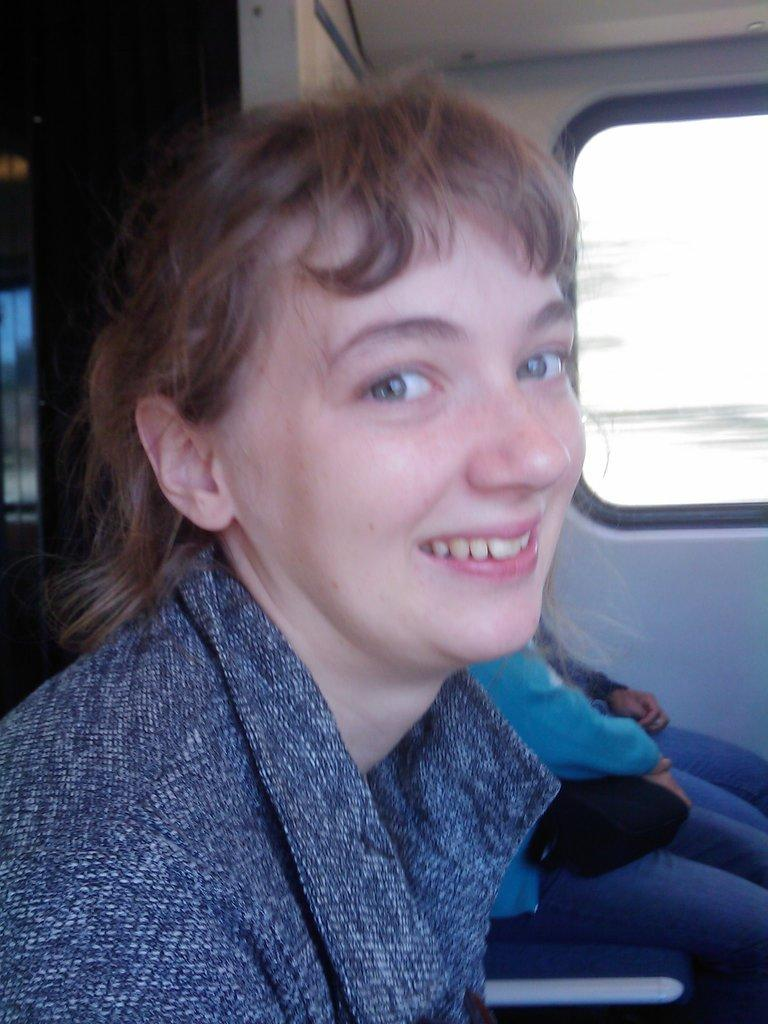Who is the main subject in the image? There is a lady in the image. Can you describe the setting in the background? There are two persons sitting in the background. What architectural feature is present in the image? There is a wall with a window in the image. What type of produce is being sold by the lady in the image? There is no produce visible in the image, and the lady is not selling anything. 